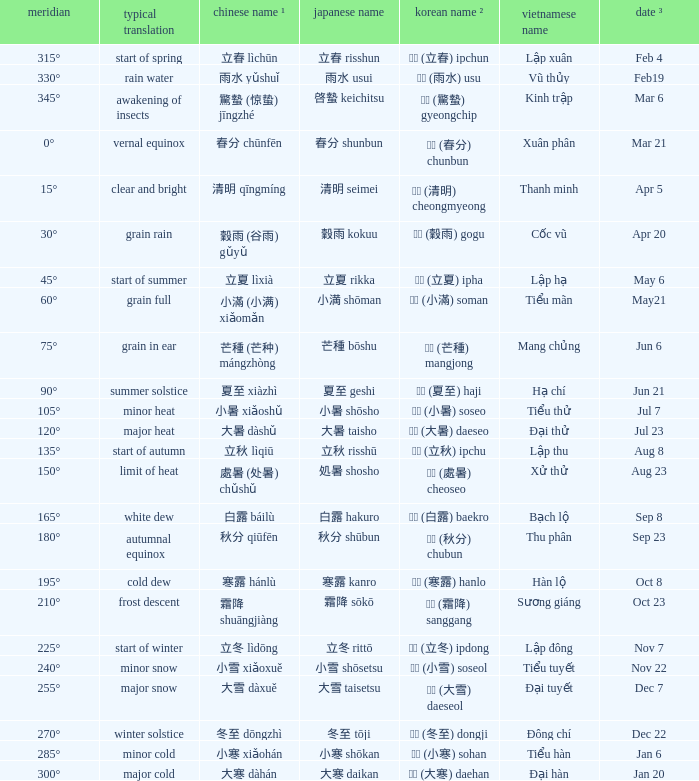When has a Korean name ² of 청명 (清明) cheongmyeong? Apr 5. 